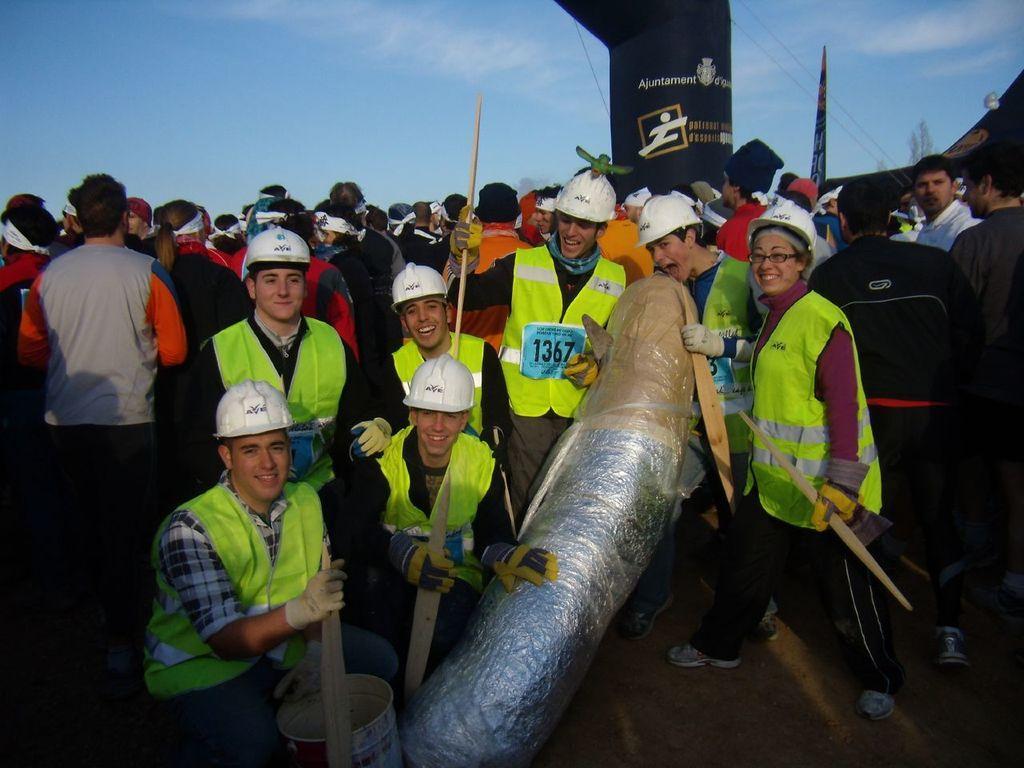Please provide a concise description of this image. In this image we can see people standing and some of them are sitting. They are holding wooden sticks. There is an object. In the background there is sky and we can see a flag. 